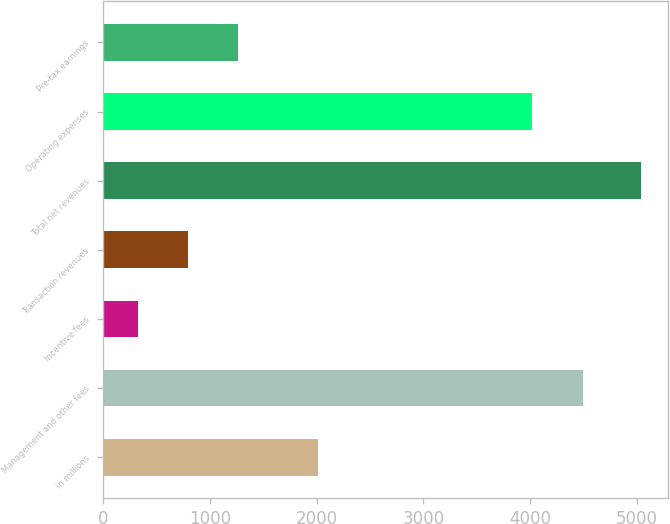Convert chart to OTSL. <chart><loc_0><loc_0><loc_500><loc_500><bar_chart><fcel>in millions<fcel>Management and other fees<fcel>Incentive fees<fcel>Transaction revenues<fcel>Total net revenues<fcel>Operating expenses<fcel>Pre-tax earnings<nl><fcel>2011<fcel>4491.1<fcel>323<fcel>794.1<fcel>5034<fcel>4020<fcel>1265.2<nl></chart> 